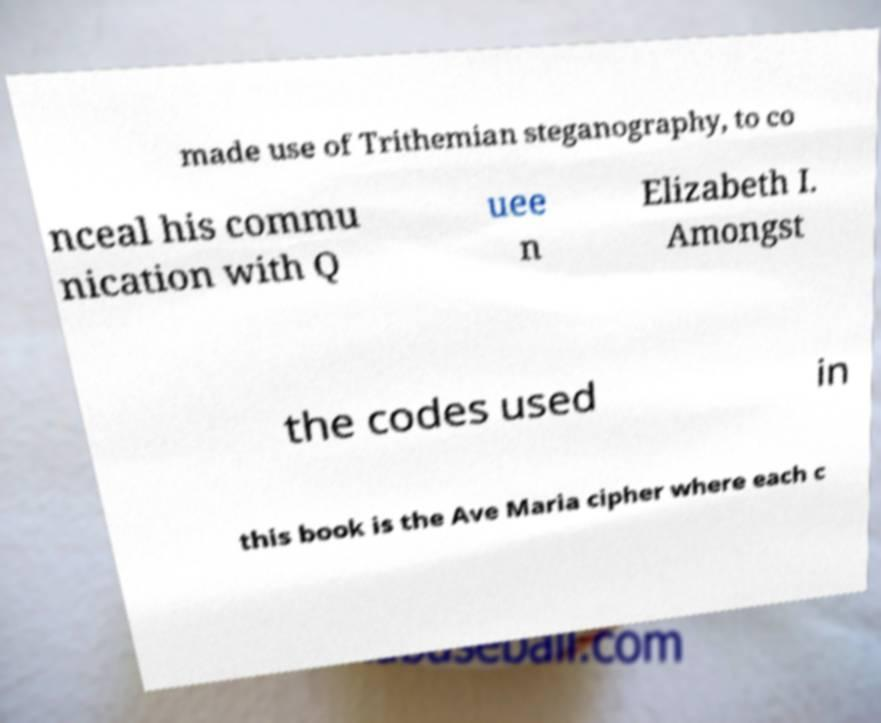I need the written content from this picture converted into text. Can you do that? made use of Trithemian steganography, to co nceal his commu nication with Q uee n Elizabeth I. Amongst the codes used in this book is the Ave Maria cipher where each c 